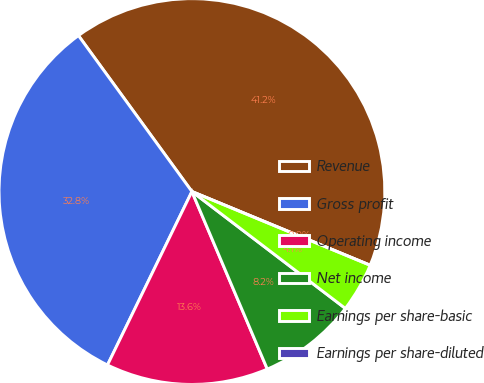Convert chart. <chart><loc_0><loc_0><loc_500><loc_500><pie_chart><fcel>Revenue<fcel>Gross profit<fcel>Operating income<fcel>Net income<fcel>Earnings per share-basic<fcel>Earnings per share-diluted<nl><fcel>41.25%<fcel>32.78%<fcel>13.6%<fcel>8.25%<fcel>4.12%<fcel>0.0%<nl></chart> 